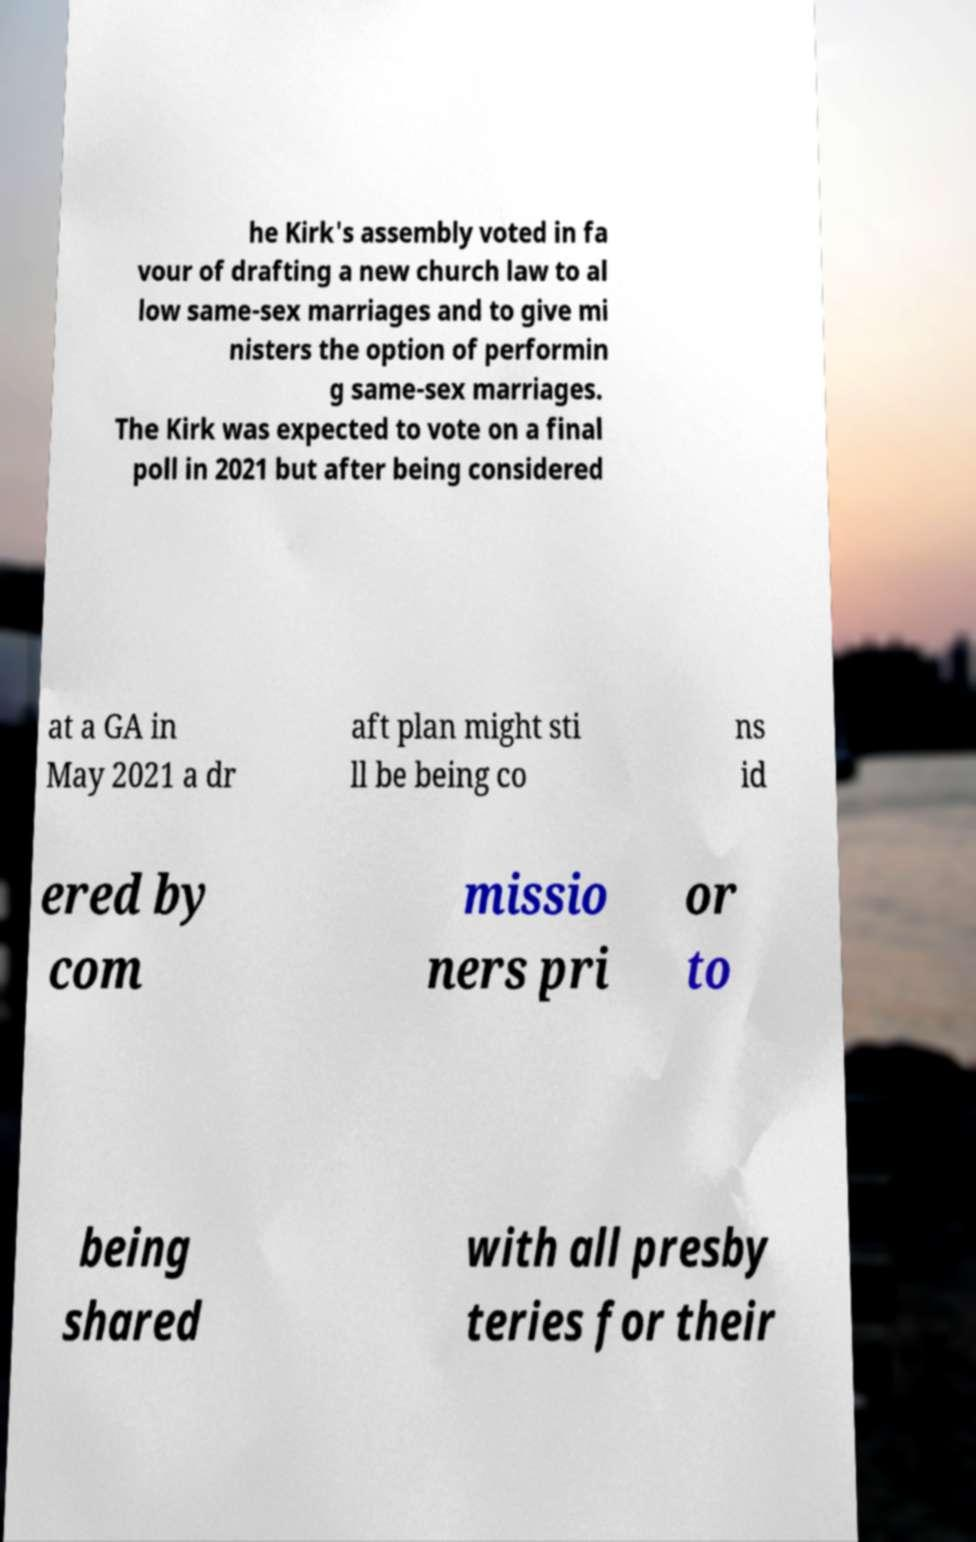Please read and relay the text visible in this image. What does it say? he Kirk's assembly voted in fa vour of drafting a new church law to al low same-sex marriages and to give mi nisters the option of performin g same-sex marriages. The Kirk was expected to vote on a final poll in 2021 but after being considered at a GA in May 2021 a dr aft plan might sti ll be being co ns id ered by com missio ners pri or to being shared with all presby teries for their 